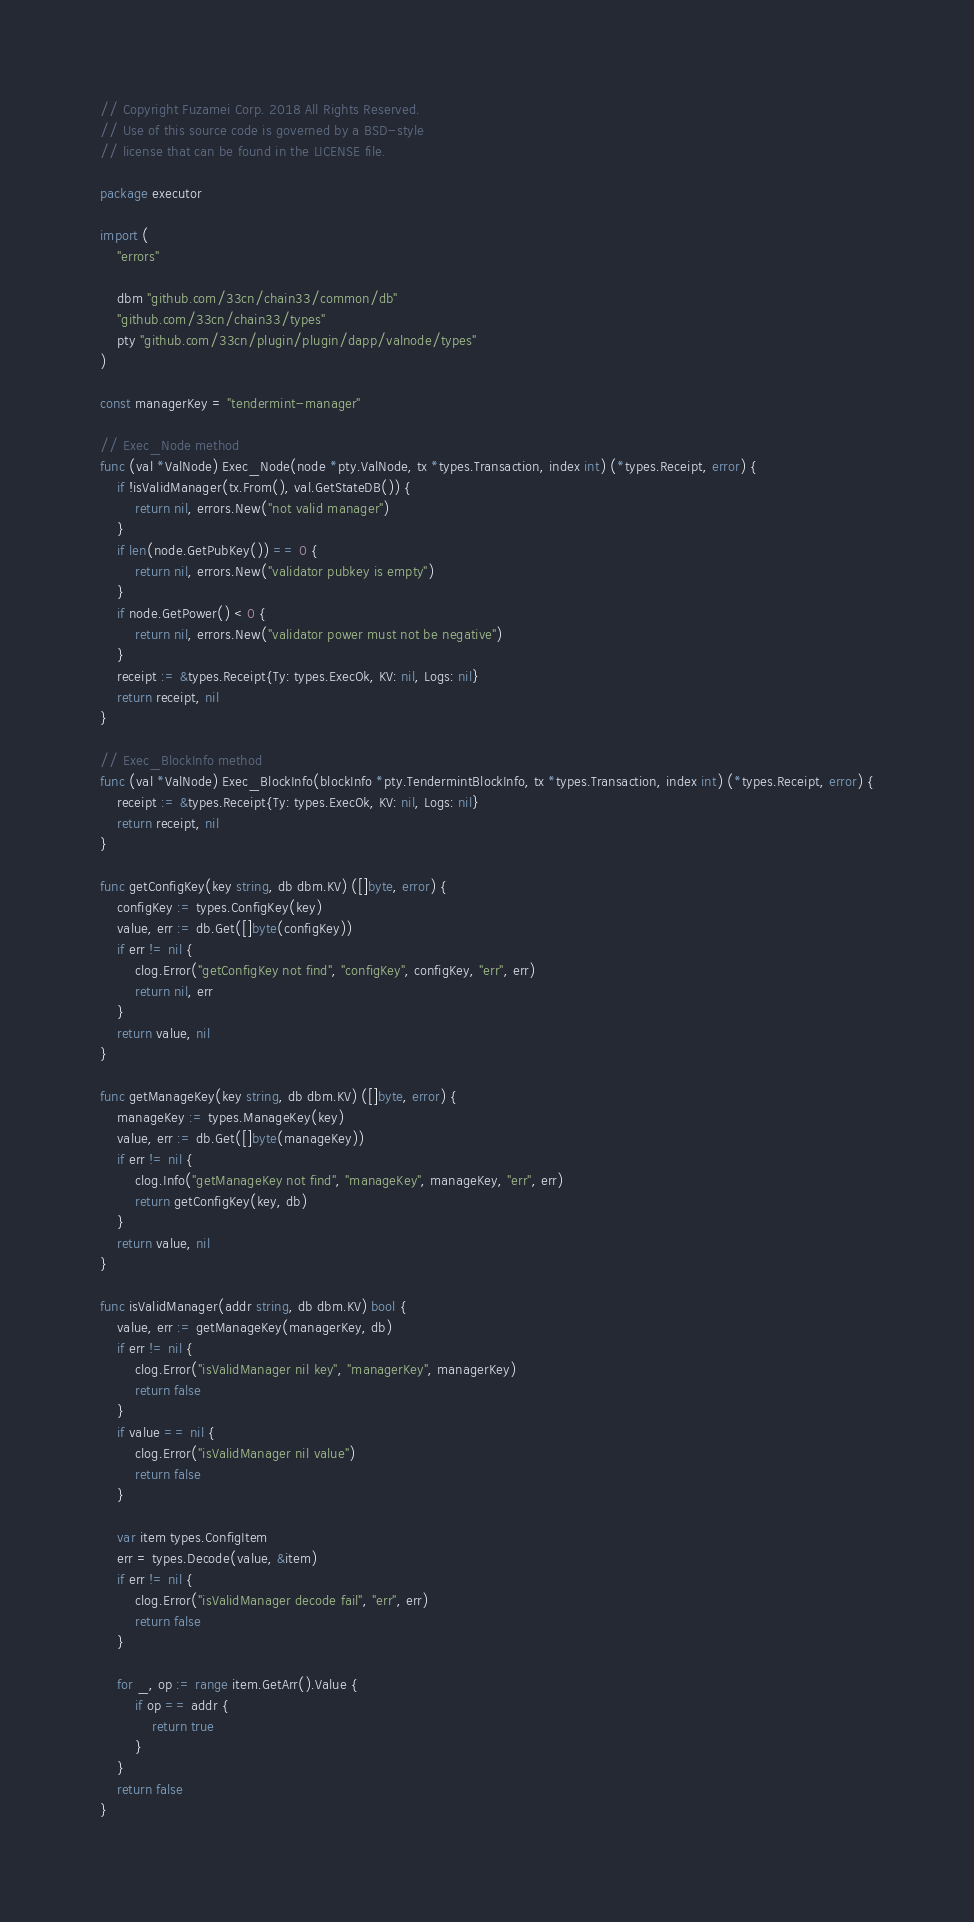<code> <loc_0><loc_0><loc_500><loc_500><_Go_>// Copyright Fuzamei Corp. 2018 All Rights Reserved.
// Use of this source code is governed by a BSD-style
// license that can be found in the LICENSE file.

package executor

import (
	"errors"

	dbm "github.com/33cn/chain33/common/db"
	"github.com/33cn/chain33/types"
	pty "github.com/33cn/plugin/plugin/dapp/valnode/types"
)

const managerKey = "tendermint-manager"

// Exec_Node method
func (val *ValNode) Exec_Node(node *pty.ValNode, tx *types.Transaction, index int) (*types.Receipt, error) {
	if !isValidManager(tx.From(), val.GetStateDB()) {
		return nil, errors.New("not valid manager")
	}
	if len(node.GetPubKey()) == 0 {
		return nil, errors.New("validator pubkey is empty")
	}
	if node.GetPower() < 0 {
		return nil, errors.New("validator power must not be negative")
	}
	receipt := &types.Receipt{Ty: types.ExecOk, KV: nil, Logs: nil}
	return receipt, nil
}

// Exec_BlockInfo method
func (val *ValNode) Exec_BlockInfo(blockInfo *pty.TendermintBlockInfo, tx *types.Transaction, index int) (*types.Receipt, error) {
	receipt := &types.Receipt{Ty: types.ExecOk, KV: nil, Logs: nil}
	return receipt, nil
}

func getConfigKey(key string, db dbm.KV) ([]byte, error) {
	configKey := types.ConfigKey(key)
	value, err := db.Get([]byte(configKey))
	if err != nil {
		clog.Error("getConfigKey not find", "configKey", configKey, "err", err)
		return nil, err
	}
	return value, nil
}

func getManageKey(key string, db dbm.KV) ([]byte, error) {
	manageKey := types.ManageKey(key)
	value, err := db.Get([]byte(manageKey))
	if err != nil {
		clog.Info("getManageKey not find", "manageKey", manageKey, "err", err)
		return getConfigKey(key, db)
	}
	return value, nil
}

func isValidManager(addr string, db dbm.KV) bool {
	value, err := getManageKey(managerKey, db)
	if err != nil {
		clog.Error("isValidManager nil key", "managerKey", managerKey)
		return false
	}
	if value == nil {
		clog.Error("isValidManager nil value")
		return false
	}

	var item types.ConfigItem
	err = types.Decode(value, &item)
	if err != nil {
		clog.Error("isValidManager decode fail", "err", err)
		return false
	}

	for _, op := range item.GetArr().Value {
		if op == addr {
			return true
		}
	}
	return false
}
</code> 